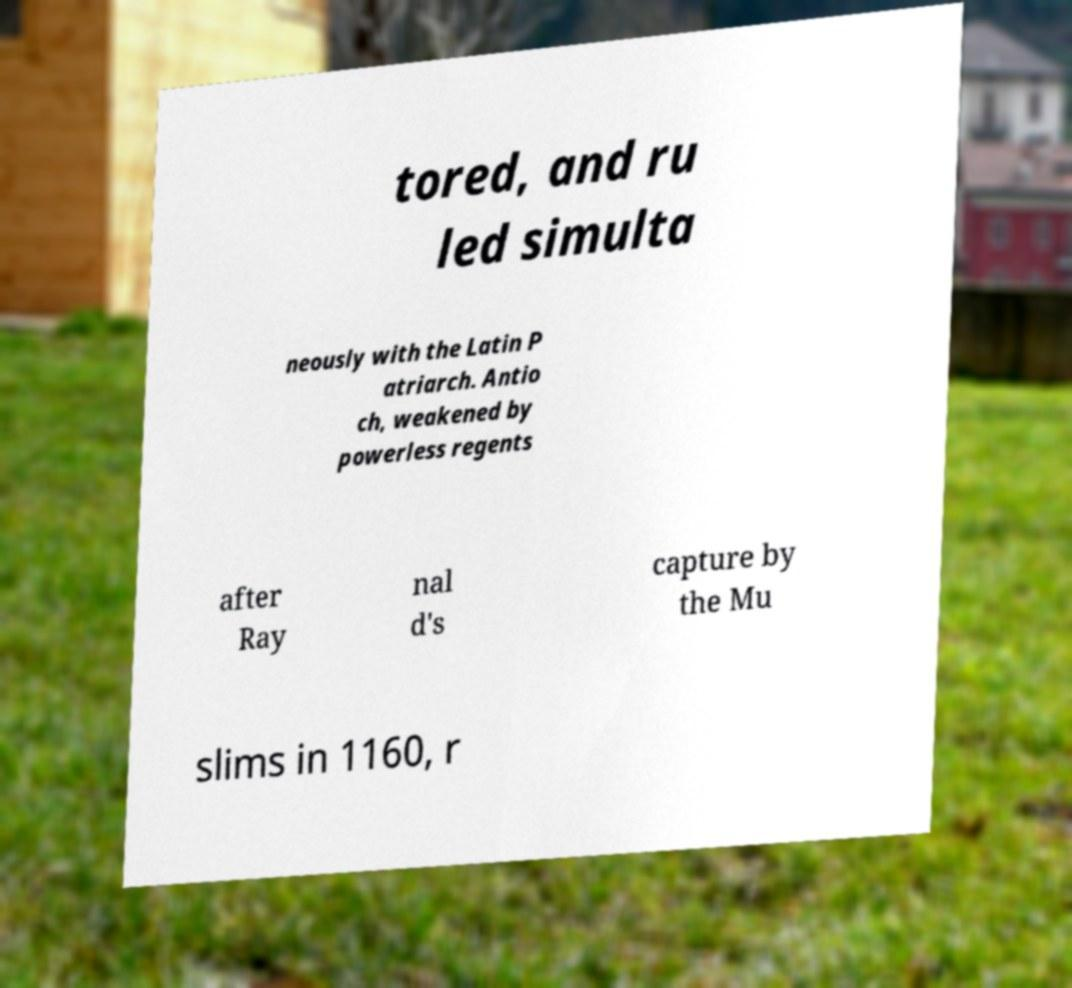There's text embedded in this image that I need extracted. Can you transcribe it verbatim? tored, and ru led simulta neously with the Latin P atriarch. Antio ch, weakened by powerless regents after Ray nal d's capture by the Mu slims in 1160, r 